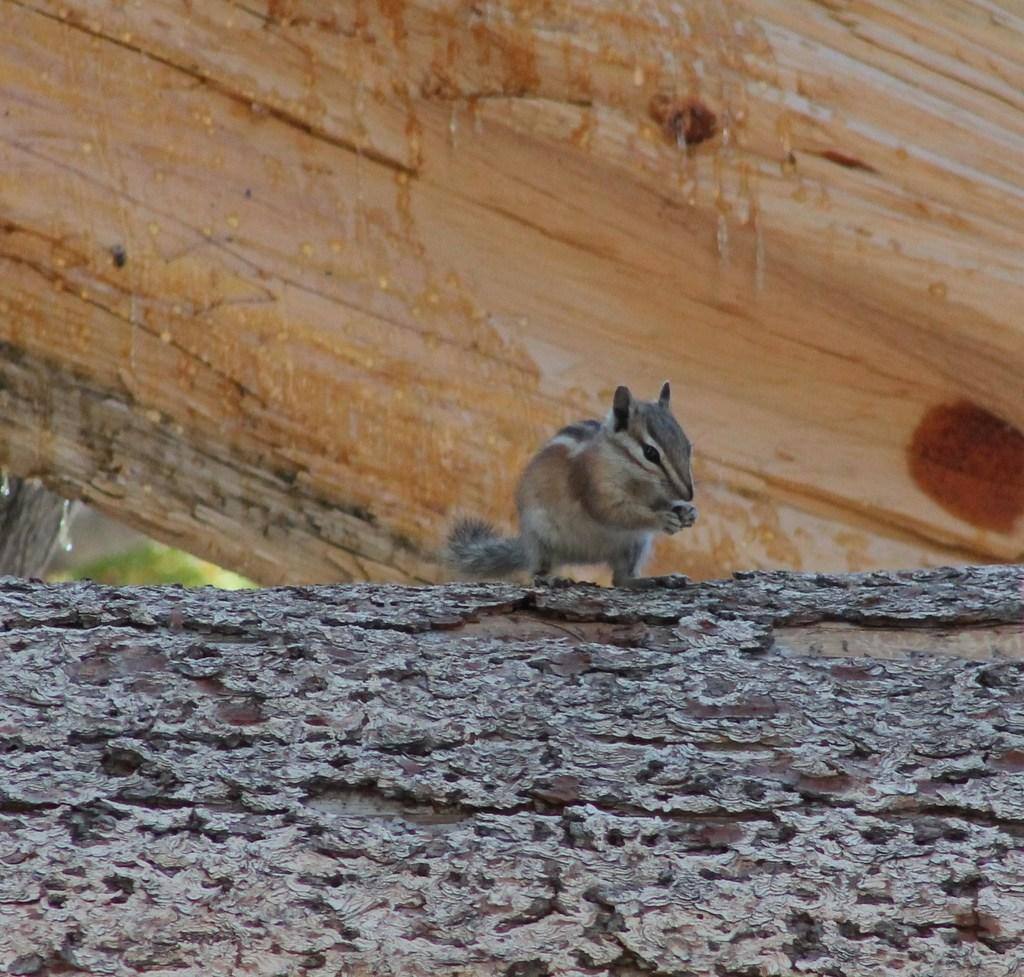What is the main subject in the center of the image? There is a squirrel in the center of the image. What is the squirrel standing on? The squirrel is on a log. Can you describe any other logs visible in the image? There is another log at the top side of the image. What type of door can be seen on the squirrel's body in the image? There is no door present on the squirrel's body in the image. 